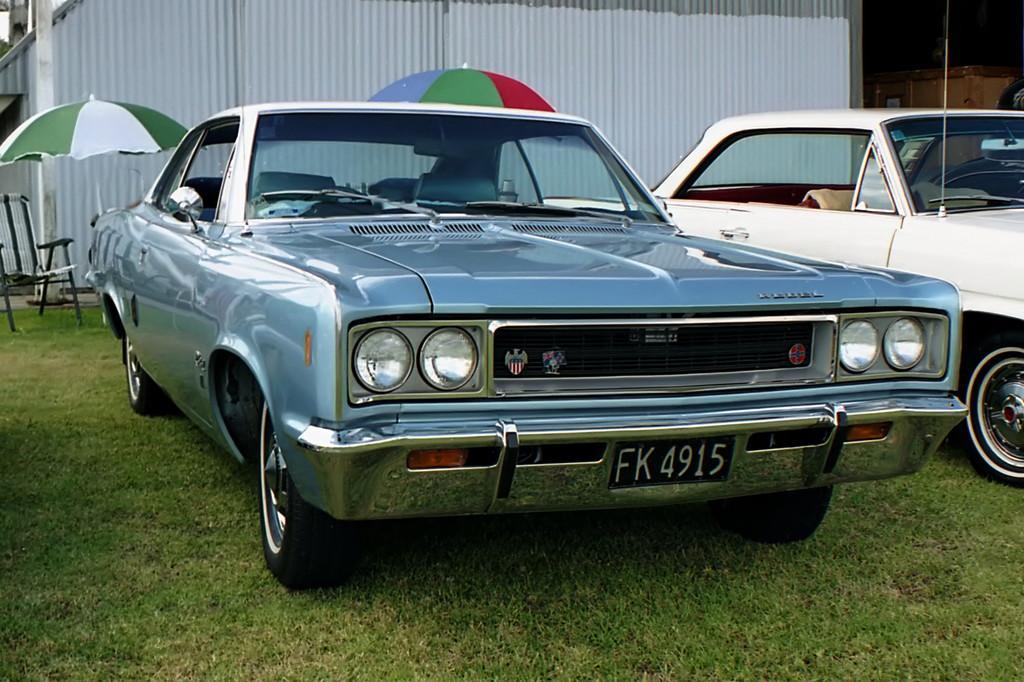What type of vehicles are on the grass in the image? There are cars on the grass in the image. What type of furniture can be seen in the background? There is a chair in the background. What objects are present in the background to provide shade? There are umbrellas in the background. What type of structure is visible in the background? There is a wall in the background. What vertical object can be seen in the background? There is a pole in the background. What type of eggs can be seen on the pole in the image? There are no eggs present on the pole in the image. 